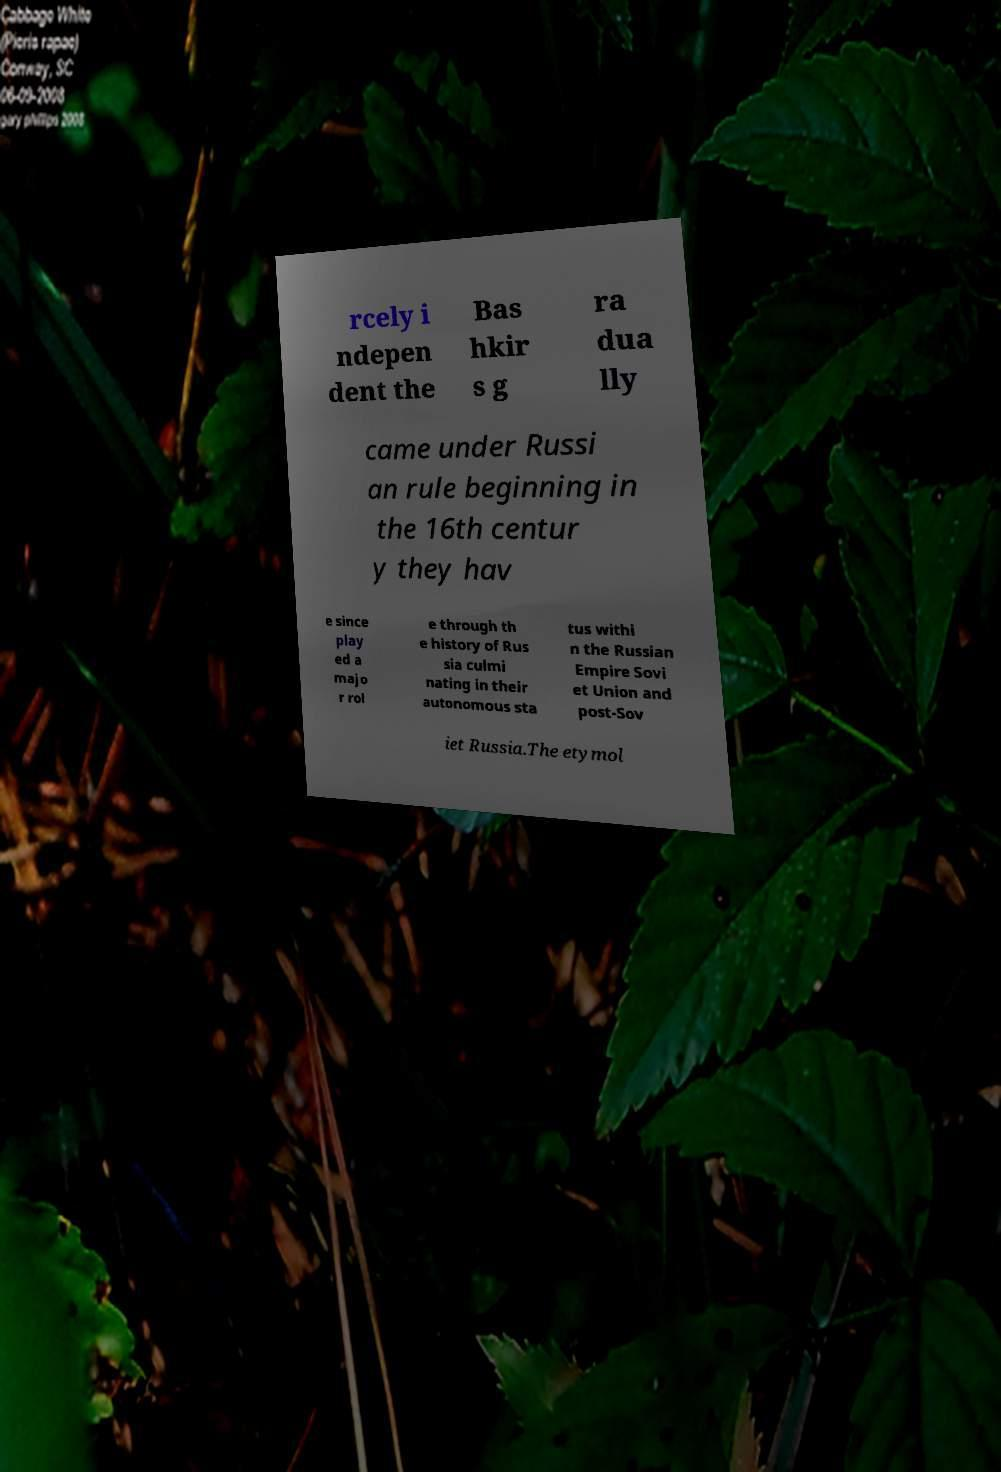Please read and relay the text visible in this image. What does it say? rcely i ndepen dent the Bas hkir s g ra dua lly came under Russi an rule beginning in the 16th centur y they hav e since play ed a majo r rol e through th e history of Rus sia culmi nating in their autonomous sta tus withi n the Russian Empire Sovi et Union and post-Sov iet Russia.The etymol 